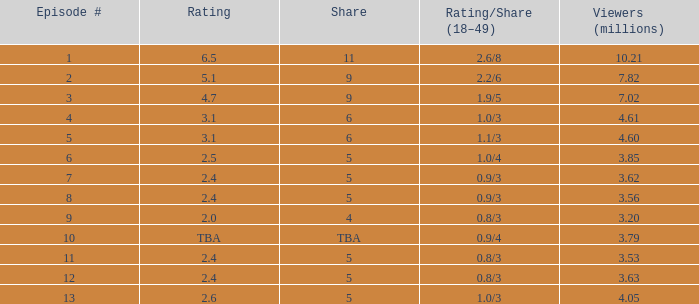1/3? None. 